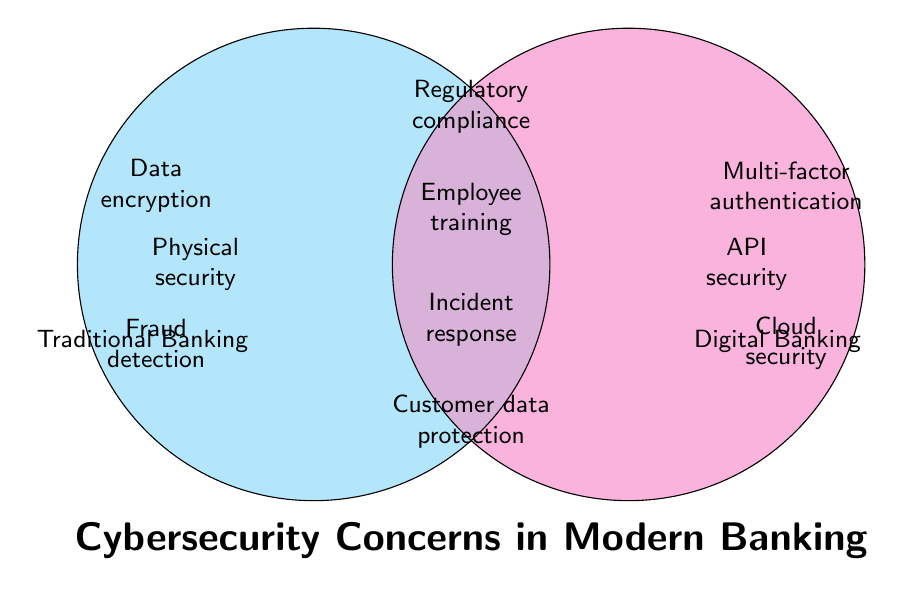Which cybersecurity concerns are unique to traditional banking? To identify the cybersecurity concerns unique to traditional banking, look at the segment of the Venn diagram labeled "Traditional Banking" but not intersecting with "Digital Banking."
Answer: Data encryption, Fraud detection, Physical security Which cybersecurity concerns are shared by both traditional and digital banking? The segment of the Venn diagram where the two circles intersect represents the shared cybersecurity concerns between traditional and digital banking.
Answer: Regulatory compliance, Employee training, Incident response planning, Customer data protection What cybersecurity concerns are unique to digital banking? To find the cybersecurity concerns unique to digital banking, observe the section labeled "Digital Banking" that does not overlap with "Traditional Banking."
Answer: Multi-factor authentication, Cloud security, API security How many cybersecurity concerns are specific to traditional banking but not shared with digital banking? Count the items listed in the "Traditional Banking" section that do not intersect with the "Digital Banking" section.
Answer: Three Between traditional and digital banking, which has more unique cybersecurity concerns? Compare the number of unique cybersecurity concerns listed in the non-intersecting sections of both the "Traditional Banking" and "Digital Banking" circles.
Answer: Digital banking What cybersecurity concerns listed are related to compliance and regulations? Look for topics that specifically mention compliance or regulations. These can often be found in the intersecting area that represents shared concerns.
Answer: Regulatory compliance What is the total number of cybersecurity concerns shown in the diagram? Add the number of unique and shared cybersecurity concerns together. Unique traditional (3) + unique digital (3) + shared (4) = 10.
Answer: Ten Which cybersecurity concerns related to employee preparedness are shared by both models? Search the intersecting section for cybersecurity concerns that relate to employee readiness and behavior.
Answer: Employee training, Incident response planning Are there more concerns related to customer protection in traditional banking or in shared concerns? Identify segments related to customer protection in both traditional banking and the shared section, then compare their counts.
Answer: Shared concerns 